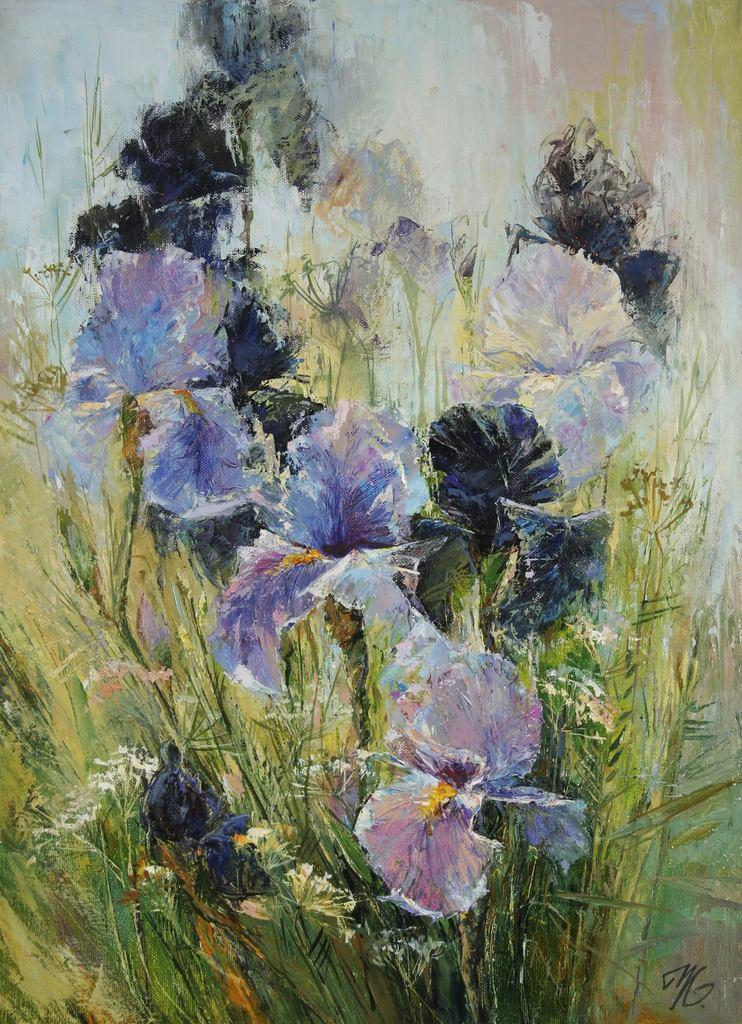What is the main subject of the image? There is a painting in the image. What is depicted in the painting? The painting depicts plants and flowers. What route does the bit take to reach the mom in the image? There is no bit or mom present in the image; it only features a painting of plants and flowers. 